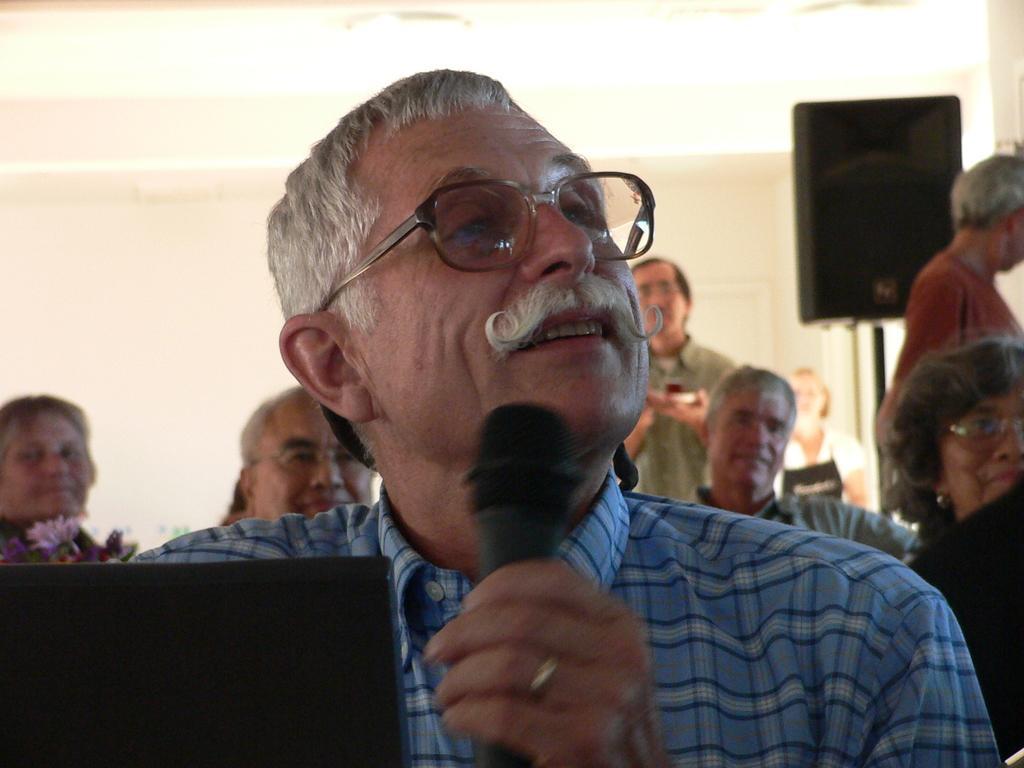Can you describe this image briefly? In this picture we can see man smiling wore spectacle holding mic in his hand and in the background we can see group of people looking at something, speakers, flower here we can see laptop. 